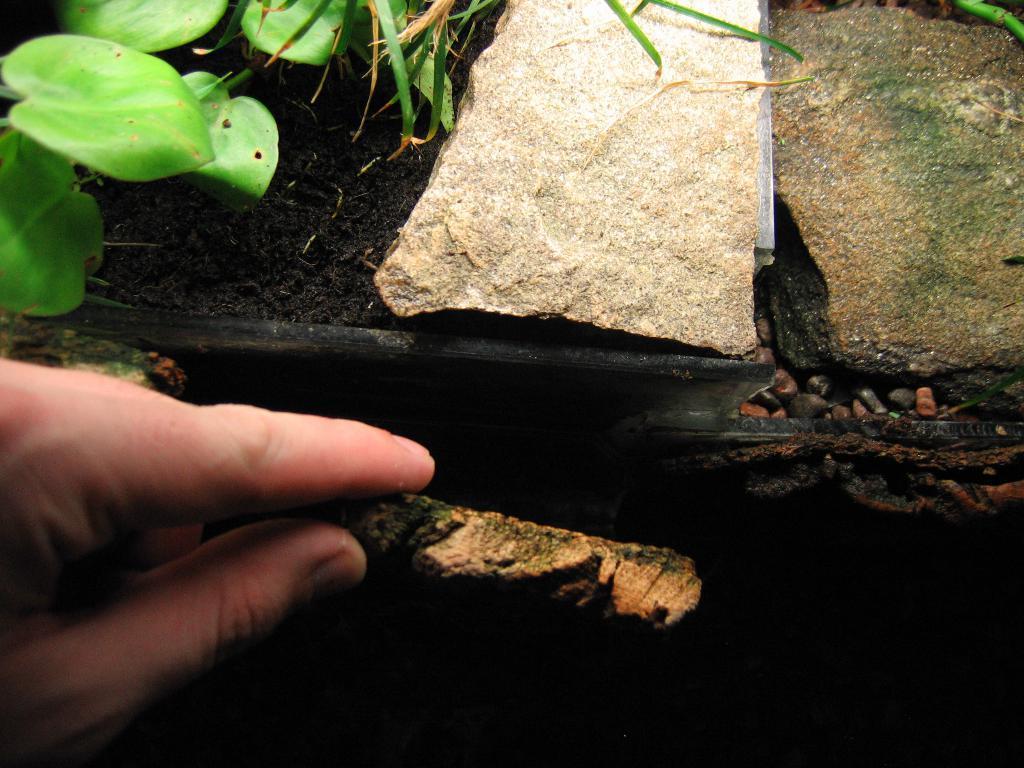Please provide a concise description of this image. In this image we can see a person holding an object, leaves and stones. 